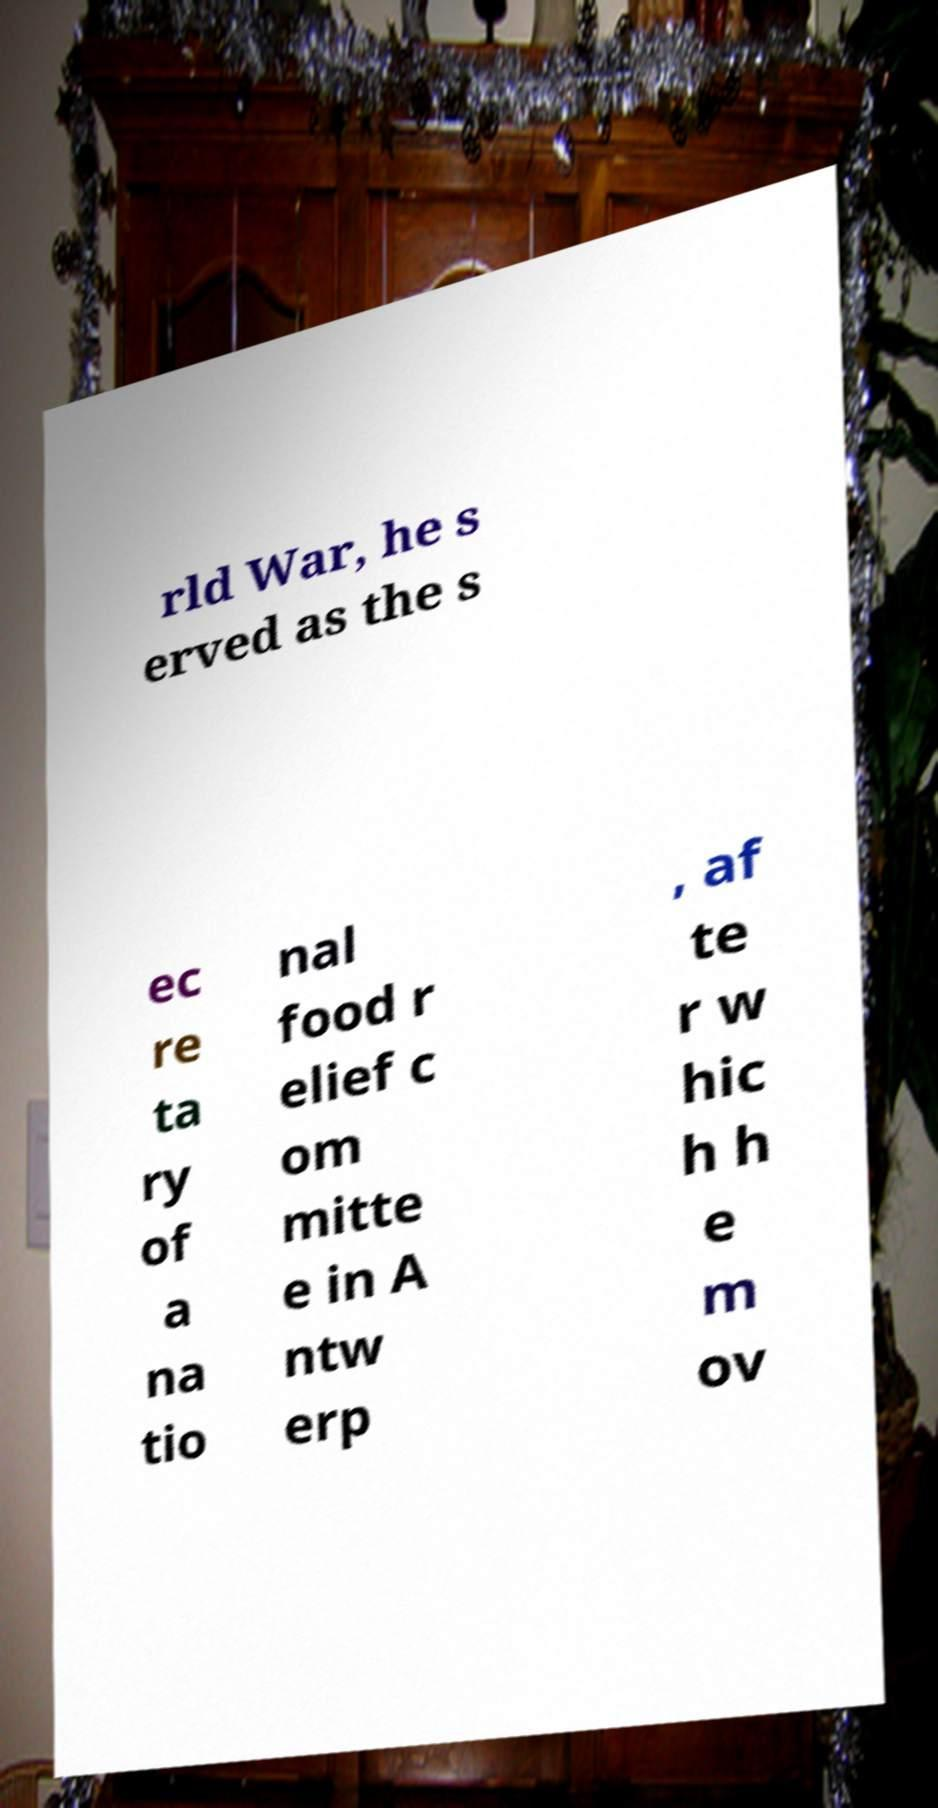Could you extract and type out the text from this image? rld War, he s erved as the s ec re ta ry of a na tio nal food r elief c om mitte e in A ntw erp , af te r w hic h h e m ov 